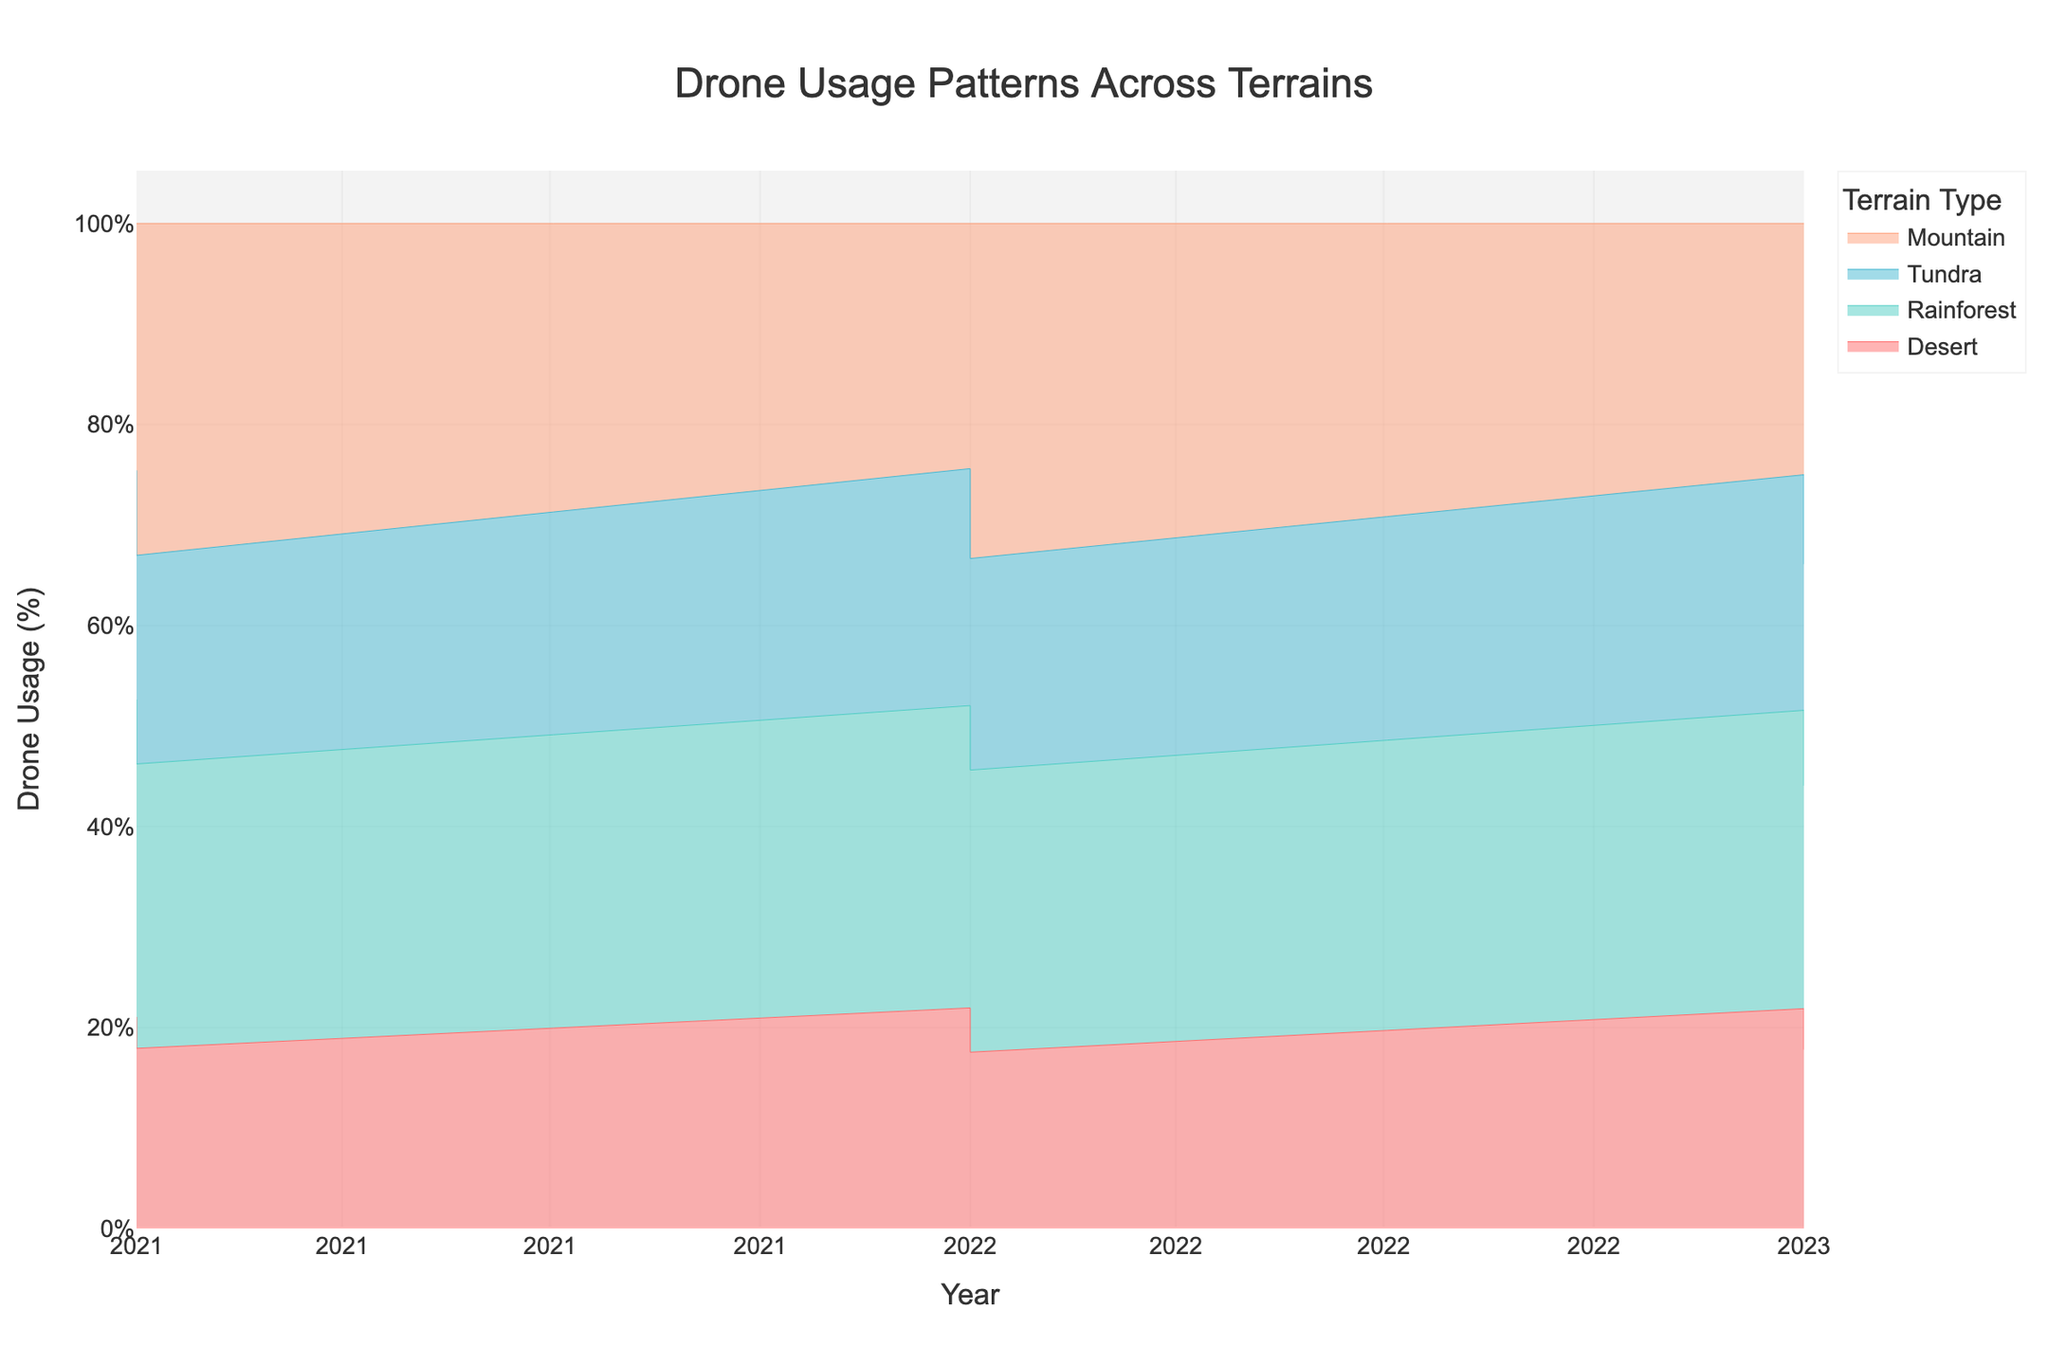Which terrain type has the highest drone usage in 2023? To find this, look at the stream graph for 2023 and identify the terrain type with the largest percentage. Visually, observe the color with the highest area in 2023.
Answer: Mountain Is the drone usage for the Sahara Desert increasing or decreasing from 2021 to 2023? Compare the stream graph areas representing the Sahara Desert from 2021 to 2023. The size of the area should be noticeably smaller by 2023.
Answer: Decreasing What's the overall trend in drone usage for rainforests from 2021 to 2023? To determine this, observe the areas associated with the rainforests (Amazon Rainforest and Congo Rainforest) across the years. The areas appear to be slightly increasing in size over the years.
Answer: Increasing How does the drone usage in the Atacama Desert in 2023 compare to 2021? Look at the specific area for the Atacama Desert in both years. The area is larger in 2023 compared to 2021, indicating an increase.
Answer: Higher in 2023 Which year had the highest drone usage in the Himalayas? Observe the stream graph and identify the year for the Himalayas. The area for the Himalayas in 2023 is the highest as seen by its large size compared to previous years.
Answer: 2023 Between 2021 and 2023, which terrain type had the most consistent drone usage? Consistency can be observed by identifying a terrain type that shows little change in area size over the years. The areas representing the rainforests appear to be relatively stable.
Answer: Rainforest What can we infer about the relative popularity of tundra terrains for drone usage over the years? Analyze the size variation of the areas for the tundra terrains from 2021 to 2023. There is a steady increase over the years.
Answer: Increasing Comparatively, which terrain type showed the least fluctuation in drone usage hours between 2021 and 2023? Identify the terrain type with the least change in the size of the area graphically. The areas representing the Mountains seem to show more consistent usage hours.
Answer: Mountain 